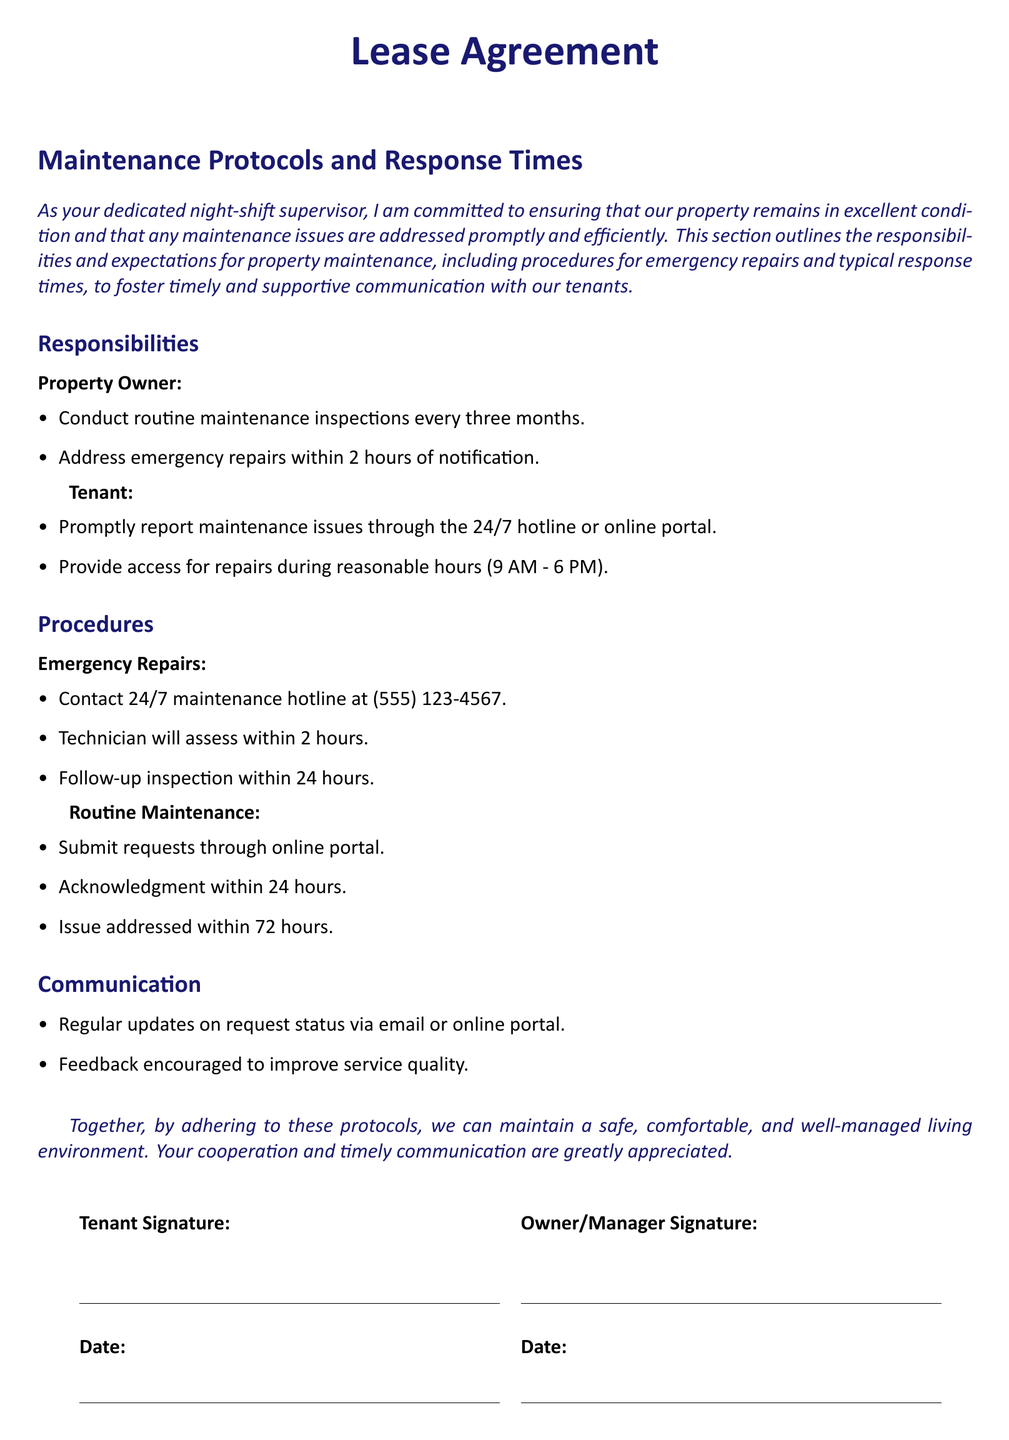what is the contact number for emergency repairs? The document specifies the 24/7 maintenance hotline at (555) 123-4567 for emergency repairs.
Answer: (555) 123-4567 how quickly will emergency repairs be addressed? According to the lease agreement, emergency repairs should be addressed within 2 hours of notification.
Answer: 2 hours what are the routine maintenance request acknowledgment times? The document states that routine maintenance requests will receive acknowledgment within 24 hours.
Answer: 24 hours who is responsible for conducting routine maintenance inspections? The property owner is responsible for conducting routine maintenance inspections every three months as per the agreement.
Answer: Property Owner what hours should tenants provide access for repairs? The lease states that tenants should provide access for repairs during reasonable hours from 9 AM to 6 PM.
Answer: 9 AM - 6 PM how frequently are routine maintenance inspections conducted? The property owner conducts routine maintenance inspections every three months.
Answer: every three months what is the timeframe for addressing routine maintenance issues? The lease indicates that issues will be addressed within 72 hours after acknowledgment of routine maintenance requests.
Answer: 72 hours what is encouraged to improve service quality? The document encourages feedback from tenants to improve service quality.
Answer: Feedback what happens after an emergency repair assessment? A follow-up inspection is scheduled within 24 hours after an emergency repair assessment.
Answer: within 24 hours 